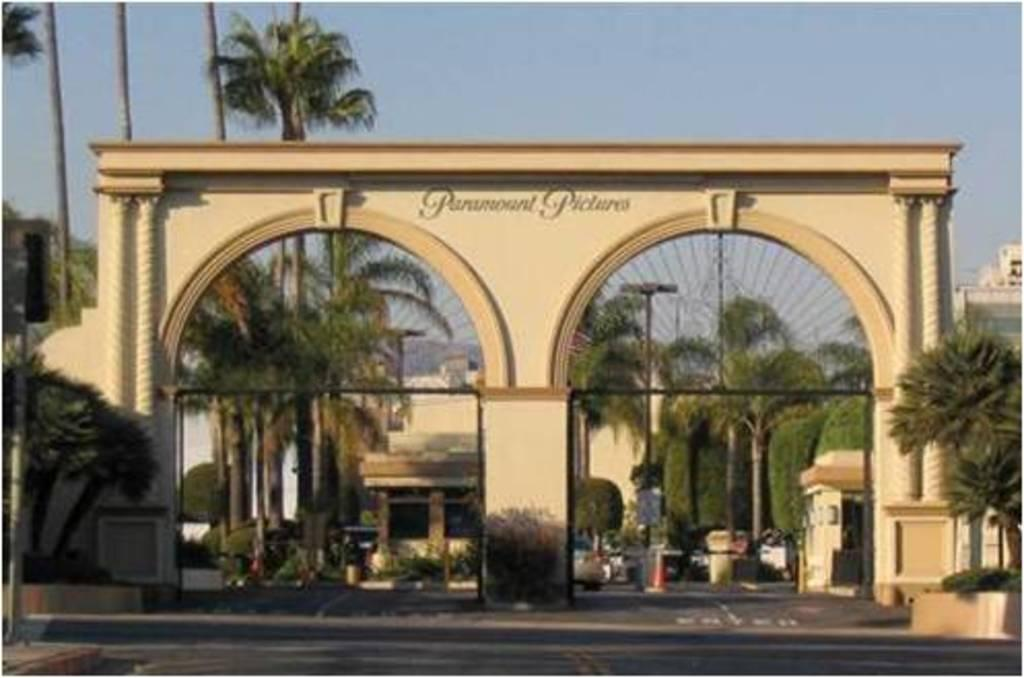What type of structure can be seen in the image? There is an arch in the image. What is unique about the arch? The arch has drills on it. Is there any text on the arch? Yes, there is text on the arch. What else can be seen in the image besides the arch? There is a road, poles, trees, buildings, plants, and the sky visible in the image. What time of day is it in the image, and how does the anger of the person affect the scene? The time of day and the person's anger are not mentioned or depicted in the image. The image only shows an arch with drills and text, a road, poles, trees, buildings, plants, and the sky. 